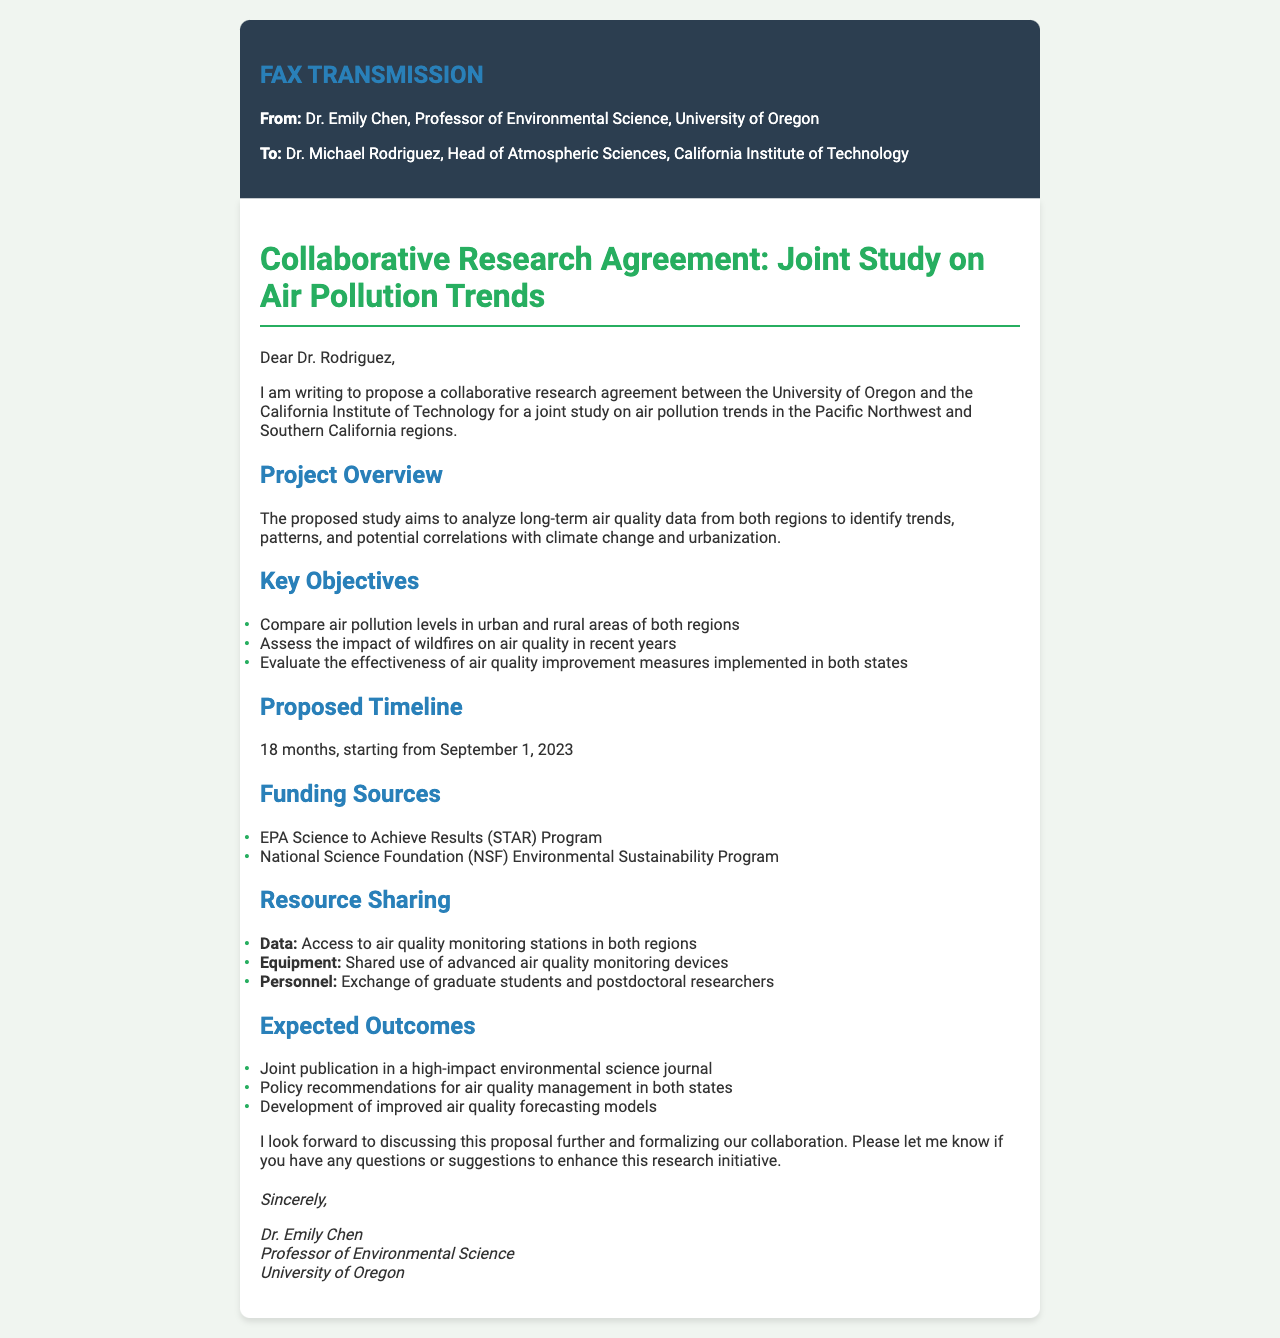What is the proposing institution? The proposing institution is mentioned in the document as the University of Oregon.
Answer: University of Oregon Who is the recipient of the fax? The recipient of the fax is identified at the beginning as Dr. Michael Rodriguez.
Answer: Dr. Michael Rodriguez What is the study's primary focus? The primary focus of the study is to analyze long-term air quality data and identify trends and patterns.
Answer: Air pollution trends What is the proposed timeline for the research project? The document specifies that the timeline for the project is 18 months starting from a specific date.
Answer: 18 months What is one of the funding sources mentioned? The document lists specific funding sources that will support the project.
Answer: EPA Science to Achieve Results (STAR) Program What type of publication is expected from the research? The expected outcome includes a specific mention of the type of publication resulting from the research efforts.
Answer: Joint publication in a high-impact environmental science journal How many key objectives are listed in the document? The document enumerates key objectives for the study, making it clear how many there are.
Answer: Three What will be shared as resources in this collaboration? The document outlines various resources that will be shared, focusing on different types of resources.
Answer: Data, Equipment, Personnel What is a main expected outcome regarding policy? One of the expected outcomes includes recommendations that pertain to a specific area of management in environmental science.
Answer: Policy recommendations for air quality management in both states 